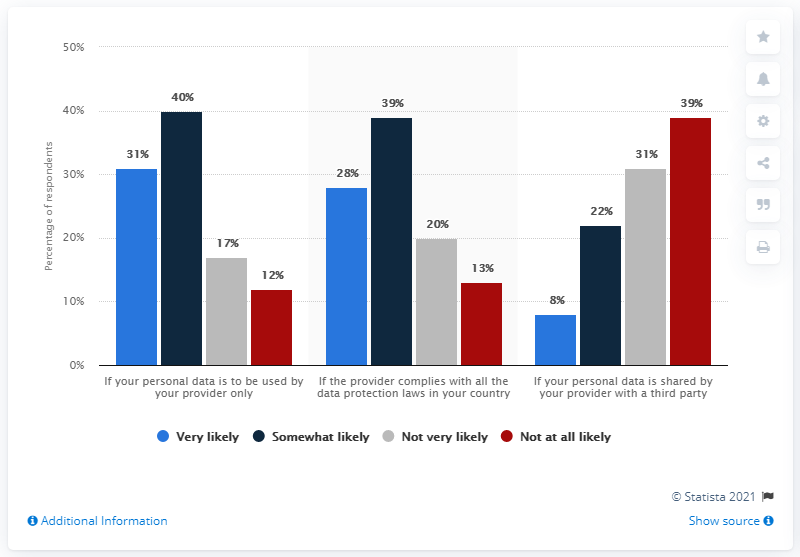Indicate a few pertinent items in this graphic. The red identifier on this graph is not at all likely. 